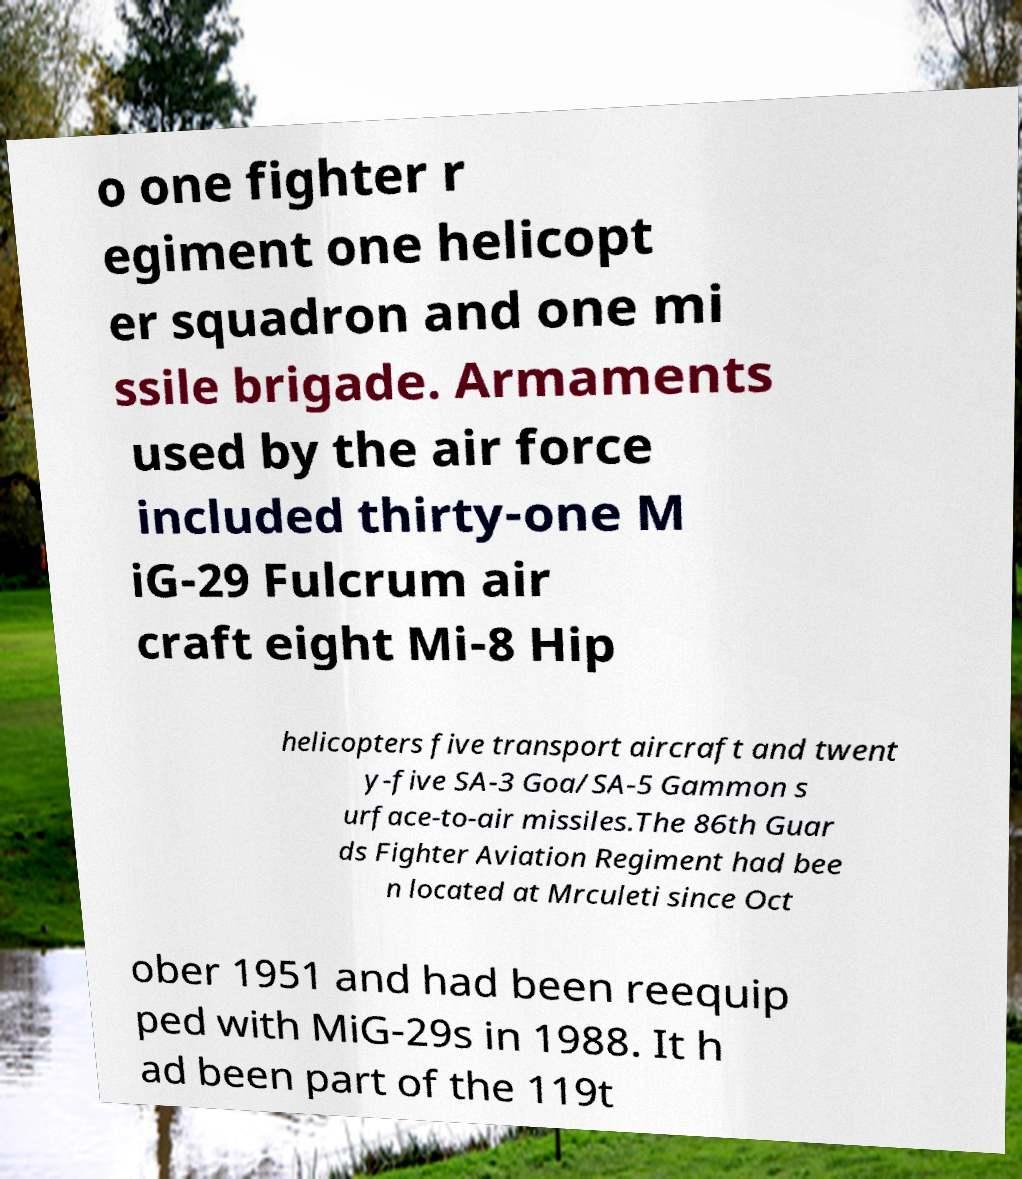Please identify and transcribe the text found in this image. o one fighter r egiment one helicopt er squadron and one mi ssile brigade. Armaments used by the air force included thirty-one M iG-29 Fulcrum air craft eight Mi-8 Hip helicopters five transport aircraft and twent y-five SA-3 Goa/SA-5 Gammon s urface-to-air missiles.The 86th Guar ds Fighter Aviation Regiment had bee n located at Mrculeti since Oct ober 1951 and had been reequip ped with MiG-29s in 1988. It h ad been part of the 119t 